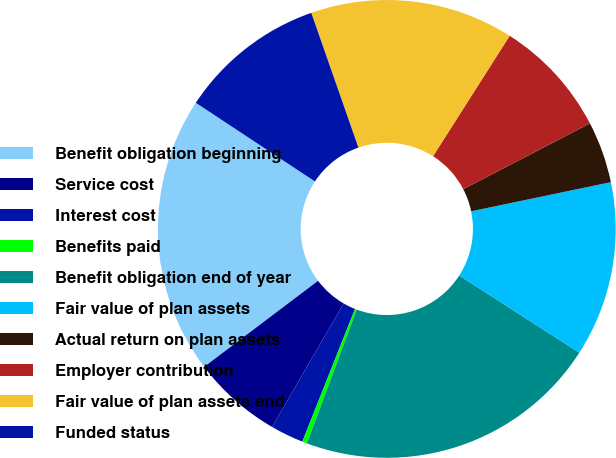<chart> <loc_0><loc_0><loc_500><loc_500><pie_chart><fcel>Benefit obligation beginning<fcel>Service cost<fcel>Interest cost<fcel>Benefits paid<fcel>Benefit obligation end of year<fcel>Fair value of plan assets<fcel>Actual return on plan assets<fcel>Employer contribution<fcel>Fair value of plan assets end<fcel>Funded status<nl><fcel>19.58%<fcel>6.35%<fcel>2.34%<fcel>0.34%<fcel>21.58%<fcel>12.37%<fcel>4.35%<fcel>8.36%<fcel>14.37%<fcel>10.36%<nl></chart> 